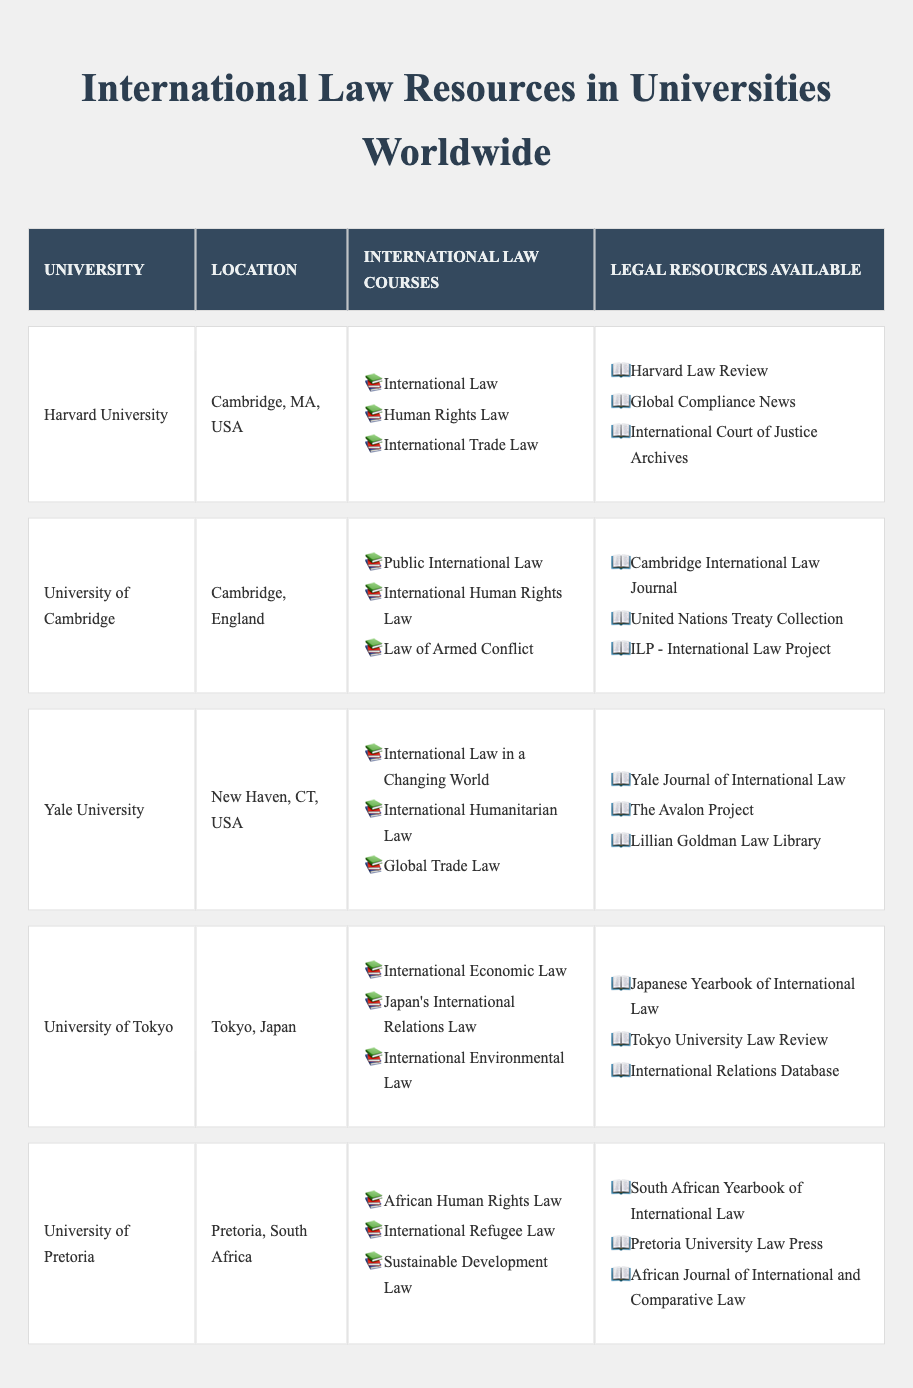What international law courses are offered at Harvard University? Harvard University offers the following courses: International Law, Human Rights Law, and International Trade Law. This information is taken directly from the table.
Answer: International Law, Human Rights Law, International Trade Law Which university located in Japan offers courses related to international law? The University of Tokyo, located in Tokyo, Japan, offers courses such as International Economic Law, Japan's International Relations Law, and International Environmental Law, which are listed in the table under the location Japan.
Answer: University of Tokyo How many international law courses does the University of Pretoria offer? The University of Pretoria offers three international law courses: African Human Rights Law, International Refugee Law, and Sustainable Development Law. This count is derived from the list provided in the table for that university.
Answer: Three Does King's College London offer a course on International Criminal Law? Yes, King's College London offers a course titled International Criminal Law, which is explicitly mentioned in the table under their international law courses.
Answer: Yes Which university has the most legal resources available listed in the table? Both Harvard University and Yale University have three legal resources listed each, while all other universities have fewer than three. To determine this, we simply count the resources listed per university.
Answer: Harvard University and Yale University How many different legal resources are available across all listed universities? To find the total, we count the unique legal resources available at each university and sum them: Harvard (3) + Cambridge (3) + Yale (3) + Tokyo (3) + Pretoria (3) + Buenos Aires (3) + King's College (3) + Singapore (3) + ANU (3) = 27 resources in total.
Answer: 27 Which two universities offer the same number of international law courses? All universities listed offer three international law courses each. To determine this, we can see from the table that every university has an identical count of three courses.
Answer: All universities (3 each) Is the legal resource 'International Court of Justice Archives' listed under any university? Yes, the legal resource 'International Court of Justice Archives' is listed under Harvard University in the table.
Answer: Yes Are there any universities that include ‘International Environmental Law’ in their course offerings? Yes, both the University of Tokyo and National University of Singapore offer a course titled International Environmental Law. This information can be confirmed by scanning the course listings in the table.
Answer: Yes, two universities Which university located in Argentina offers courses in International Law and Human Rights? The University of Buenos Aires, located in Buenos Aires, Argentina, offers the course titled International Law and Human Rights. This is clearly stated in the course list for that university in the table.
Answer: University of Buenos Aires 